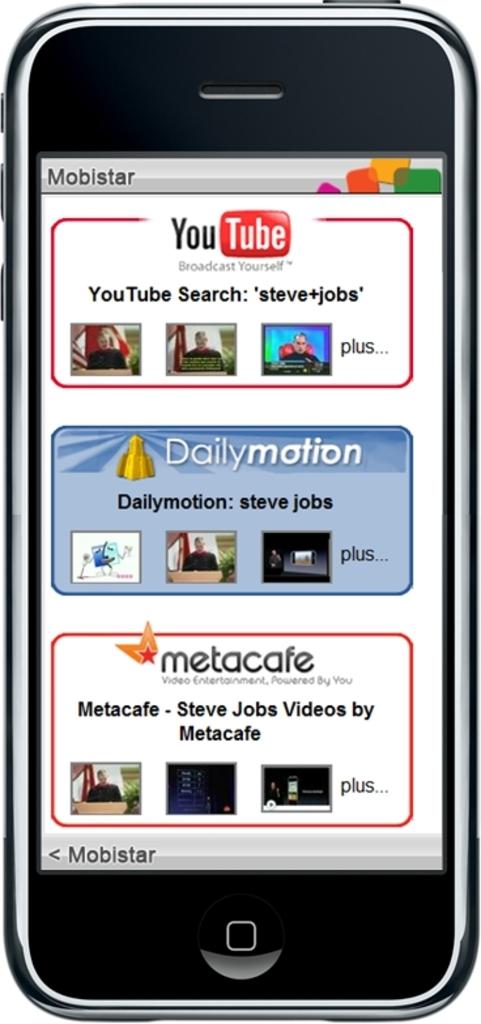What video streaming service is shown at the top of the smartphone screen?
Ensure brevity in your answer.  Youtube. 